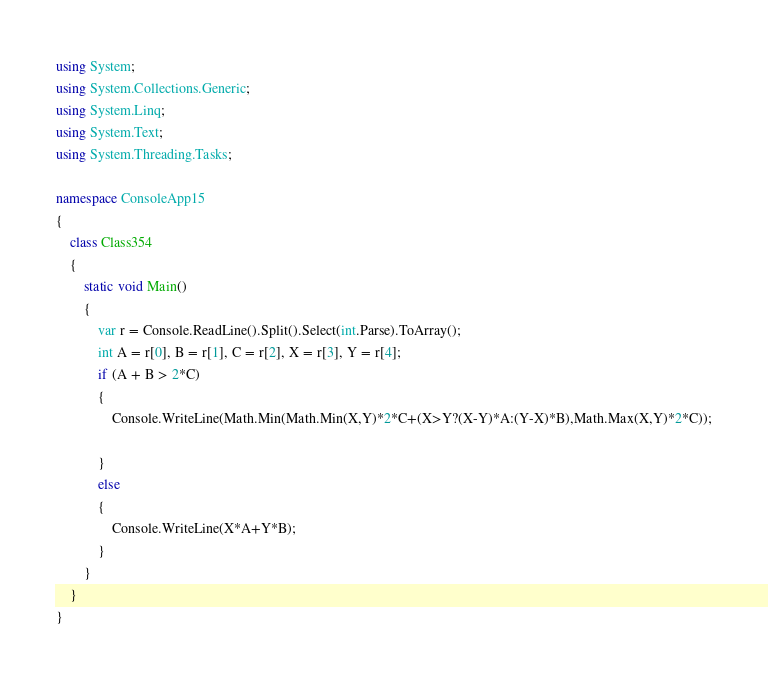<code> <loc_0><loc_0><loc_500><loc_500><_C#_>using System;
using System.Collections.Generic;
using System.Linq;
using System.Text;
using System.Threading.Tasks;

namespace ConsoleApp15
{
    class Class354
    {
        static void Main()
        {
            var r = Console.ReadLine().Split().Select(int.Parse).ToArray();
            int A = r[0], B = r[1], C = r[2], X = r[3], Y = r[4];
            if (A + B > 2*C)
            {
                Console.WriteLine(Math.Min(Math.Min(X,Y)*2*C+(X>Y?(X-Y)*A:(Y-X)*B),Math.Max(X,Y)*2*C));

            }
            else
            {
                Console.WriteLine(X*A+Y*B);
            }
        }
    }
}
</code> 